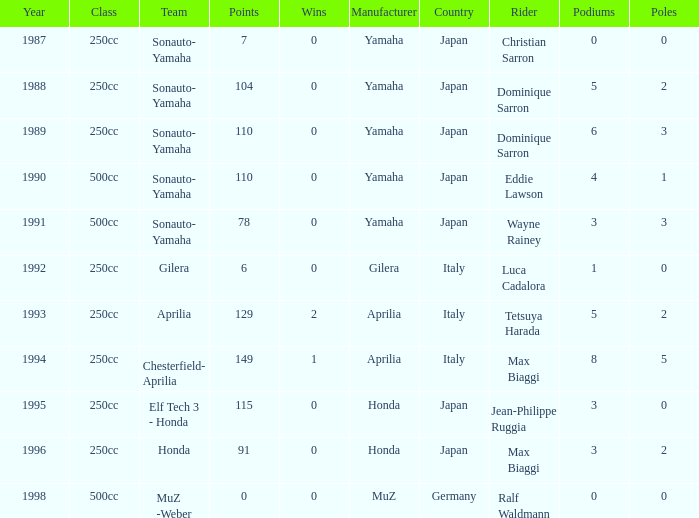How many wins did the team, which had more than 110 points, have in 1989? None. 